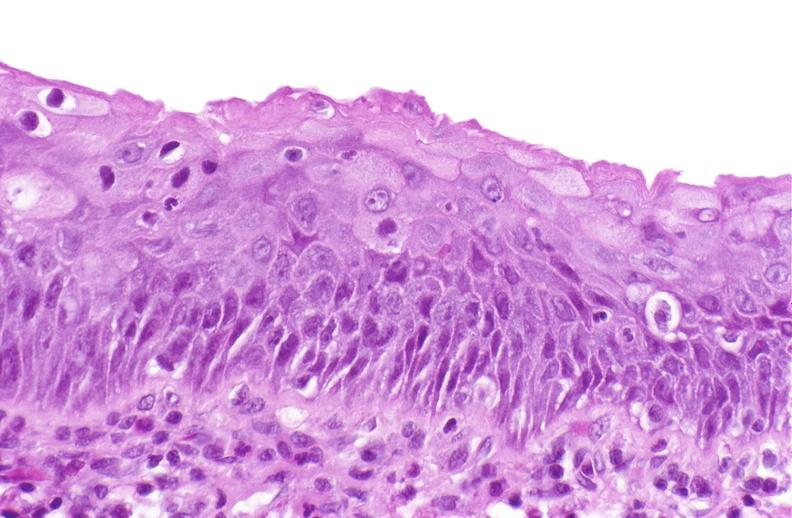what is present?
Answer the question using a single word or phrase. Urinary 